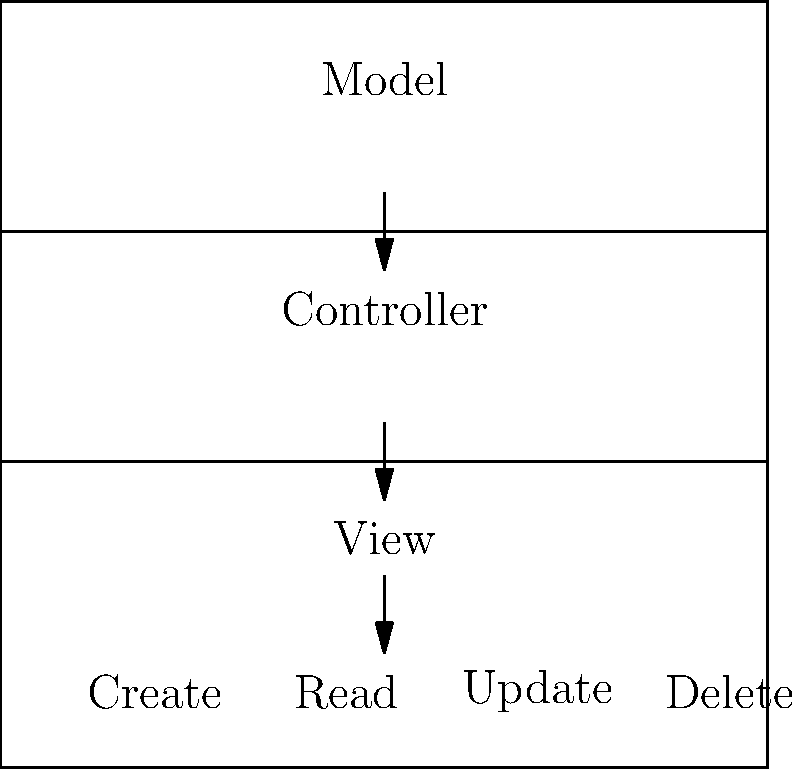In the Yii framework, which component of the MVC architecture is responsible for handling user requests and coordinating between the Model and View? To understand the implementation of CRUD functionality in Yii using the MVC architecture, let's break down the roles of each component:

1. Model: Represents the data structure and business logic. In Yii, models are typically classes that extend from `yii\base\Model` or `yii\db\ActiveRecord`.

2. View: Responsible for presenting data to users. In Yii, views are PHP scripts that contain HTML and PHP code for rendering the user interface.

3. Controller: Acts as an intermediary between the Model and View. It processes user requests, interacts with the Model to fetch or update data, and then passes that data to the View for rendering.

In a CRUD (Create, Read, Update, Delete) operation:

- The Controller receives the user's request (e.g., to create a new record).
- It then interacts with the Model to perform the requested operation on the data.
- Finally, it selects the appropriate View to display the results to the user.

The component that handles user requests and coordinates between the Model and View is the Controller. It's the central piece that manages the flow of data and control in the MVC architecture.
Answer: Controller 